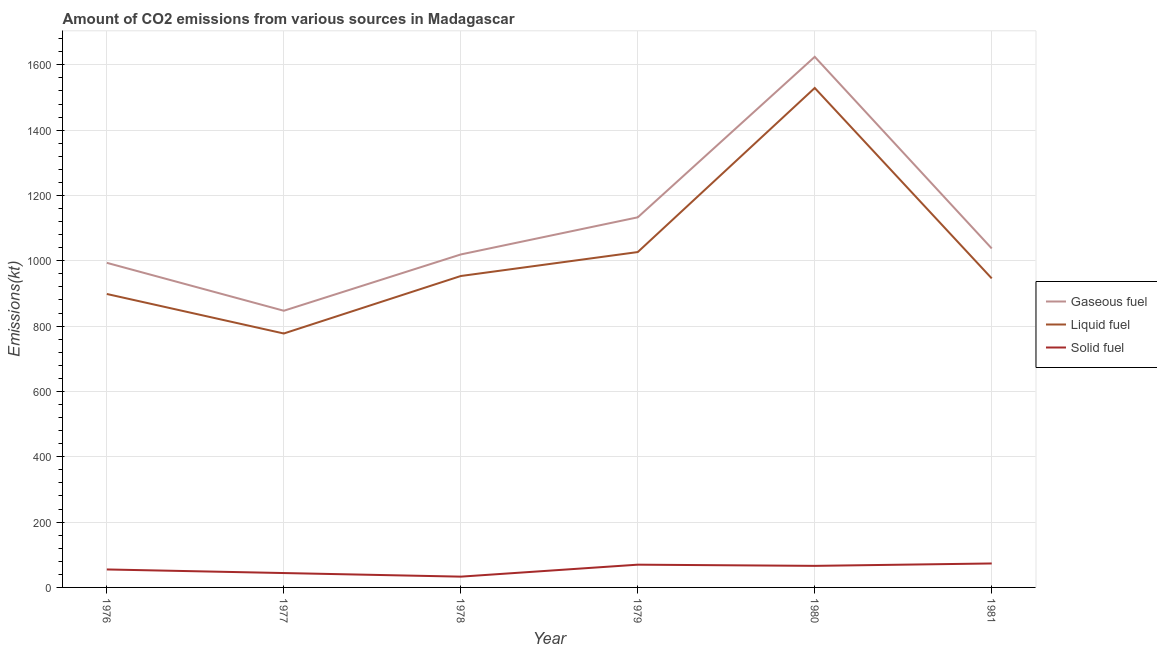How many different coloured lines are there?
Give a very brief answer. 3. Does the line corresponding to amount of co2 emissions from liquid fuel intersect with the line corresponding to amount of co2 emissions from solid fuel?
Keep it short and to the point. No. Is the number of lines equal to the number of legend labels?
Ensure brevity in your answer.  Yes. What is the amount of co2 emissions from liquid fuel in 1976?
Provide a succinct answer. 898.41. Across all years, what is the maximum amount of co2 emissions from gaseous fuel?
Your answer should be compact. 1624.48. Across all years, what is the minimum amount of co2 emissions from solid fuel?
Ensure brevity in your answer.  33. In which year was the amount of co2 emissions from solid fuel maximum?
Give a very brief answer. 1981. In which year was the amount of co2 emissions from solid fuel minimum?
Your answer should be compact. 1978. What is the total amount of co2 emissions from solid fuel in the graph?
Your answer should be compact. 341.03. What is the difference between the amount of co2 emissions from liquid fuel in 1977 and that in 1979?
Give a very brief answer. -249.36. What is the difference between the amount of co2 emissions from liquid fuel in 1979 and the amount of co2 emissions from solid fuel in 1978?
Offer a very short reply. 993.76. What is the average amount of co2 emissions from gaseous fuel per year?
Keep it short and to the point. 1109.27. In the year 1981, what is the difference between the amount of co2 emissions from solid fuel and amount of co2 emissions from liquid fuel?
Give a very brief answer. -872.75. What is the ratio of the amount of co2 emissions from solid fuel in 1976 to that in 1980?
Offer a very short reply. 0.83. Is the amount of co2 emissions from gaseous fuel in 1976 less than that in 1977?
Your answer should be compact. No. Is the difference between the amount of co2 emissions from solid fuel in 1976 and 1981 greater than the difference between the amount of co2 emissions from gaseous fuel in 1976 and 1981?
Provide a short and direct response. Yes. What is the difference between the highest and the second highest amount of co2 emissions from liquid fuel?
Make the answer very short. 502.38. What is the difference between the highest and the lowest amount of co2 emissions from liquid fuel?
Give a very brief answer. 751.73. Is it the case that in every year, the sum of the amount of co2 emissions from gaseous fuel and amount of co2 emissions from liquid fuel is greater than the amount of co2 emissions from solid fuel?
Give a very brief answer. Yes. Does the amount of co2 emissions from liquid fuel monotonically increase over the years?
Ensure brevity in your answer.  No. Is the amount of co2 emissions from liquid fuel strictly greater than the amount of co2 emissions from gaseous fuel over the years?
Give a very brief answer. No. Is the amount of co2 emissions from liquid fuel strictly less than the amount of co2 emissions from solid fuel over the years?
Provide a succinct answer. No. How many years are there in the graph?
Make the answer very short. 6. Does the graph contain any zero values?
Keep it short and to the point. No. Does the graph contain grids?
Give a very brief answer. Yes. Where does the legend appear in the graph?
Provide a short and direct response. Center right. How many legend labels are there?
Your answer should be very brief. 3. How are the legend labels stacked?
Give a very brief answer. Vertical. What is the title of the graph?
Keep it short and to the point. Amount of CO2 emissions from various sources in Madagascar. Does "Taxes on goods and services" appear as one of the legend labels in the graph?
Your response must be concise. No. What is the label or title of the Y-axis?
Offer a terse response. Emissions(kt). What is the Emissions(kt) of Gaseous fuel in 1976?
Your response must be concise. 993.76. What is the Emissions(kt) in Liquid fuel in 1976?
Your response must be concise. 898.41. What is the Emissions(kt) of Solid fuel in 1976?
Give a very brief answer. 55.01. What is the Emissions(kt) in Gaseous fuel in 1977?
Your answer should be very brief. 847.08. What is the Emissions(kt) in Liquid fuel in 1977?
Your answer should be compact. 777.4. What is the Emissions(kt) in Solid fuel in 1977?
Your answer should be very brief. 44. What is the Emissions(kt) of Gaseous fuel in 1978?
Make the answer very short. 1019.43. What is the Emissions(kt) in Liquid fuel in 1978?
Give a very brief answer. 953.42. What is the Emissions(kt) in Solid fuel in 1978?
Keep it short and to the point. 33. What is the Emissions(kt) in Gaseous fuel in 1979?
Provide a short and direct response. 1133.1. What is the Emissions(kt) of Liquid fuel in 1979?
Your answer should be compact. 1026.76. What is the Emissions(kt) of Solid fuel in 1979?
Keep it short and to the point. 69.67. What is the Emissions(kt) of Gaseous fuel in 1980?
Your answer should be very brief. 1624.48. What is the Emissions(kt) of Liquid fuel in 1980?
Make the answer very short. 1529.14. What is the Emissions(kt) in Solid fuel in 1980?
Your response must be concise. 66.01. What is the Emissions(kt) in Gaseous fuel in 1981?
Offer a very short reply. 1037.76. What is the Emissions(kt) in Liquid fuel in 1981?
Give a very brief answer. 946.09. What is the Emissions(kt) in Solid fuel in 1981?
Make the answer very short. 73.34. Across all years, what is the maximum Emissions(kt) in Gaseous fuel?
Provide a succinct answer. 1624.48. Across all years, what is the maximum Emissions(kt) in Liquid fuel?
Give a very brief answer. 1529.14. Across all years, what is the maximum Emissions(kt) of Solid fuel?
Keep it short and to the point. 73.34. Across all years, what is the minimum Emissions(kt) in Gaseous fuel?
Give a very brief answer. 847.08. Across all years, what is the minimum Emissions(kt) of Liquid fuel?
Your answer should be very brief. 777.4. Across all years, what is the minimum Emissions(kt) of Solid fuel?
Your answer should be compact. 33. What is the total Emissions(kt) of Gaseous fuel in the graph?
Your answer should be very brief. 6655.6. What is the total Emissions(kt) in Liquid fuel in the graph?
Provide a short and direct response. 6131.22. What is the total Emissions(kt) of Solid fuel in the graph?
Give a very brief answer. 341.03. What is the difference between the Emissions(kt) in Gaseous fuel in 1976 and that in 1977?
Provide a short and direct response. 146.68. What is the difference between the Emissions(kt) of Liquid fuel in 1976 and that in 1977?
Give a very brief answer. 121.01. What is the difference between the Emissions(kt) in Solid fuel in 1976 and that in 1977?
Make the answer very short. 11. What is the difference between the Emissions(kt) of Gaseous fuel in 1976 and that in 1978?
Your answer should be very brief. -25.67. What is the difference between the Emissions(kt) in Liquid fuel in 1976 and that in 1978?
Ensure brevity in your answer.  -55.01. What is the difference between the Emissions(kt) of Solid fuel in 1976 and that in 1978?
Make the answer very short. 22. What is the difference between the Emissions(kt) of Gaseous fuel in 1976 and that in 1979?
Your response must be concise. -139.35. What is the difference between the Emissions(kt) in Liquid fuel in 1976 and that in 1979?
Make the answer very short. -128.34. What is the difference between the Emissions(kt) of Solid fuel in 1976 and that in 1979?
Keep it short and to the point. -14.67. What is the difference between the Emissions(kt) in Gaseous fuel in 1976 and that in 1980?
Your response must be concise. -630.72. What is the difference between the Emissions(kt) of Liquid fuel in 1976 and that in 1980?
Give a very brief answer. -630.72. What is the difference between the Emissions(kt) of Solid fuel in 1976 and that in 1980?
Your answer should be compact. -11. What is the difference between the Emissions(kt) of Gaseous fuel in 1976 and that in 1981?
Provide a short and direct response. -44. What is the difference between the Emissions(kt) in Liquid fuel in 1976 and that in 1981?
Provide a short and direct response. -47.67. What is the difference between the Emissions(kt) in Solid fuel in 1976 and that in 1981?
Keep it short and to the point. -18.34. What is the difference between the Emissions(kt) in Gaseous fuel in 1977 and that in 1978?
Ensure brevity in your answer.  -172.35. What is the difference between the Emissions(kt) in Liquid fuel in 1977 and that in 1978?
Offer a very short reply. -176.02. What is the difference between the Emissions(kt) of Solid fuel in 1977 and that in 1978?
Your answer should be compact. 11. What is the difference between the Emissions(kt) in Gaseous fuel in 1977 and that in 1979?
Your answer should be very brief. -286.03. What is the difference between the Emissions(kt) of Liquid fuel in 1977 and that in 1979?
Your answer should be very brief. -249.36. What is the difference between the Emissions(kt) in Solid fuel in 1977 and that in 1979?
Your response must be concise. -25.67. What is the difference between the Emissions(kt) in Gaseous fuel in 1977 and that in 1980?
Offer a terse response. -777.4. What is the difference between the Emissions(kt) in Liquid fuel in 1977 and that in 1980?
Your response must be concise. -751.74. What is the difference between the Emissions(kt) of Solid fuel in 1977 and that in 1980?
Give a very brief answer. -22. What is the difference between the Emissions(kt) in Gaseous fuel in 1977 and that in 1981?
Your answer should be very brief. -190.68. What is the difference between the Emissions(kt) in Liquid fuel in 1977 and that in 1981?
Keep it short and to the point. -168.68. What is the difference between the Emissions(kt) of Solid fuel in 1977 and that in 1981?
Make the answer very short. -29.34. What is the difference between the Emissions(kt) of Gaseous fuel in 1978 and that in 1979?
Offer a very short reply. -113.68. What is the difference between the Emissions(kt) of Liquid fuel in 1978 and that in 1979?
Your response must be concise. -73.34. What is the difference between the Emissions(kt) of Solid fuel in 1978 and that in 1979?
Make the answer very short. -36.67. What is the difference between the Emissions(kt) in Gaseous fuel in 1978 and that in 1980?
Make the answer very short. -605.05. What is the difference between the Emissions(kt) of Liquid fuel in 1978 and that in 1980?
Make the answer very short. -575.72. What is the difference between the Emissions(kt) in Solid fuel in 1978 and that in 1980?
Ensure brevity in your answer.  -33. What is the difference between the Emissions(kt) of Gaseous fuel in 1978 and that in 1981?
Give a very brief answer. -18.34. What is the difference between the Emissions(kt) in Liquid fuel in 1978 and that in 1981?
Your response must be concise. 7.33. What is the difference between the Emissions(kt) in Solid fuel in 1978 and that in 1981?
Your answer should be very brief. -40.34. What is the difference between the Emissions(kt) of Gaseous fuel in 1979 and that in 1980?
Offer a very short reply. -491.38. What is the difference between the Emissions(kt) of Liquid fuel in 1979 and that in 1980?
Your response must be concise. -502.38. What is the difference between the Emissions(kt) of Solid fuel in 1979 and that in 1980?
Your response must be concise. 3.67. What is the difference between the Emissions(kt) in Gaseous fuel in 1979 and that in 1981?
Provide a succinct answer. 95.34. What is the difference between the Emissions(kt) in Liquid fuel in 1979 and that in 1981?
Provide a short and direct response. 80.67. What is the difference between the Emissions(kt) of Solid fuel in 1979 and that in 1981?
Make the answer very short. -3.67. What is the difference between the Emissions(kt) of Gaseous fuel in 1980 and that in 1981?
Give a very brief answer. 586.72. What is the difference between the Emissions(kt) of Liquid fuel in 1980 and that in 1981?
Your answer should be very brief. 583.05. What is the difference between the Emissions(kt) of Solid fuel in 1980 and that in 1981?
Give a very brief answer. -7.33. What is the difference between the Emissions(kt) in Gaseous fuel in 1976 and the Emissions(kt) in Liquid fuel in 1977?
Your response must be concise. 216.35. What is the difference between the Emissions(kt) of Gaseous fuel in 1976 and the Emissions(kt) of Solid fuel in 1977?
Your response must be concise. 949.75. What is the difference between the Emissions(kt) in Liquid fuel in 1976 and the Emissions(kt) in Solid fuel in 1977?
Your response must be concise. 854.41. What is the difference between the Emissions(kt) in Gaseous fuel in 1976 and the Emissions(kt) in Liquid fuel in 1978?
Offer a terse response. 40.34. What is the difference between the Emissions(kt) of Gaseous fuel in 1976 and the Emissions(kt) of Solid fuel in 1978?
Ensure brevity in your answer.  960.75. What is the difference between the Emissions(kt) in Liquid fuel in 1976 and the Emissions(kt) in Solid fuel in 1978?
Ensure brevity in your answer.  865.41. What is the difference between the Emissions(kt) of Gaseous fuel in 1976 and the Emissions(kt) of Liquid fuel in 1979?
Offer a terse response. -33. What is the difference between the Emissions(kt) of Gaseous fuel in 1976 and the Emissions(kt) of Solid fuel in 1979?
Provide a short and direct response. 924.08. What is the difference between the Emissions(kt) in Liquid fuel in 1976 and the Emissions(kt) in Solid fuel in 1979?
Keep it short and to the point. 828.74. What is the difference between the Emissions(kt) in Gaseous fuel in 1976 and the Emissions(kt) in Liquid fuel in 1980?
Your answer should be very brief. -535.38. What is the difference between the Emissions(kt) in Gaseous fuel in 1976 and the Emissions(kt) in Solid fuel in 1980?
Offer a terse response. 927.75. What is the difference between the Emissions(kt) of Liquid fuel in 1976 and the Emissions(kt) of Solid fuel in 1980?
Provide a short and direct response. 832.41. What is the difference between the Emissions(kt) in Gaseous fuel in 1976 and the Emissions(kt) in Liquid fuel in 1981?
Your answer should be compact. 47.67. What is the difference between the Emissions(kt) in Gaseous fuel in 1976 and the Emissions(kt) in Solid fuel in 1981?
Give a very brief answer. 920.42. What is the difference between the Emissions(kt) of Liquid fuel in 1976 and the Emissions(kt) of Solid fuel in 1981?
Offer a very short reply. 825.08. What is the difference between the Emissions(kt) of Gaseous fuel in 1977 and the Emissions(kt) of Liquid fuel in 1978?
Make the answer very short. -106.34. What is the difference between the Emissions(kt) in Gaseous fuel in 1977 and the Emissions(kt) in Solid fuel in 1978?
Offer a very short reply. 814.07. What is the difference between the Emissions(kt) of Liquid fuel in 1977 and the Emissions(kt) of Solid fuel in 1978?
Offer a very short reply. 744.4. What is the difference between the Emissions(kt) of Gaseous fuel in 1977 and the Emissions(kt) of Liquid fuel in 1979?
Make the answer very short. -179.68. What is the difference between the Emissions(kt) in Gaseous fuel in 1977 and the Emissions(kt) in Solid fuel in 1979?
Keep it short and to the point. 777.4. What is the difference between the Emissions(kt) in Liquid fuel in 1977 and the Emissions(kt) in Solid fuel in 1979?
Keep it short and to the point. 707.73. What is the difference between the Emissions(kt) in Gaseous fuel in 1977 and the Emissions(kt) in Liquid fuel in 1980?
Provide a short and direct response. -682.06. What is the difference between the Emissions(kt) of Gaseous fuel in 1977 and the Emissions(kt) of Solid fuel in 1980?
Ensure brevity in your answer.  781.07. What is the difference between the Emissions(kt) of Liquid fuel in 1977 and the Emissions(kt) of Solid fuel in 1980?
Provide a succinct answer. 711.4. What is the difference between the Emissions(kt) of Gaseous fuel in 1977 and the Emissions(kt) of Liquid fuel in 1981?
Keep it short and to the point. -99.01. What is the difference between the Emissions(kt) in Gaseous fuel in 1977 and the Emissions(kt) in Solid fuel in 1981?
Your answer should be very brief. 773.74. What is the difference between the Emissions(kt) in Liquid fuel in 1977 and the Emissions(kt) in Solid fuel in 1981?
Keep it short and to the point. 704.06. What is the difference between the Emissions(kt) of Gaseous fuel in 1978 and the Emissions(kt) of Liquid fuel in 1979?
Provide a succinct answer. -7.33. What is the difference between the Emissions(kt) of Gaseous fuel in 1978 and the Emissions(kt) of Solid fuel in 1979?
Your answer should be compact. 949.75. What is the difference between the Emissions(kt) of Liquid fuel in 1978 and the Emissions(kt) of Solid fuel in 1979?
Ensure brevity in your answer.  883.75. What is the difference between the Emissions(kt) in Gaseous fuel in 1978 and the Emissions(kt) in Liquid fuel in 1980?
Offer a very short reply. -509.71. What is the difference between the Emissions(kt) in Gaseous fuel in 1978 and the Emissions(kt) in Solid fuel in 1980?
Your answer should be compact. 953.42. What is the difference between the Emissions(kt) in Liquid fuel in 1978 and the Emissions(kt) in Solid fuel in 1980?
Keep it short and to the point. 887.41. What is the difference between the Emissions(kt) in Gaseous fuel in 1978 and the Emissions(kt) in Liquid fuel in 1981?
Offer a very short reply. 73.34. What is the difference between the Emissions(kt) of Gaseous fuel in 1978 and the Emissions(kt) of Solid fuel in 1981?
Your answer should be compact. 946.09. What is the difference between the Emissions(kt) of Liquid fuel in 1978 and the Emissions(kt) of Solid fuel in 1981?
Offer a very short reply. 880.08. What is the difference between the Emissions(kt) in Gaseous fuel in 1979 and the Emissions(kt) in Liquid fuel in 1980?
Give a very brief answer. -396.04. What is the difference between the Emissions(kt) of Gaseous fuel in 1979 and the Emissions(kt) of Solid fuel in 1980?
Offer a terse response. 1067.1. What is the difference between the Emissions(kt) of Liquid fuel in 1979 and the Emissions(kt) of Solid fuel in 1980?
Your response must be concise. 960.75. What is the difference between the Emissions(kt) in Gaseous fuel in 1979 and the Emissions(kt) in Liquid fuel in 1981?
Provide a succinct answer. 187.02. What is the difference between the Emissions(kt) in Gaseous fuel in 1979 and the Emissions(kt) in Solid fuel in 1981?
Ensure brevity in your answer.  1059.76. What is the difference between the Emissions(kt) of Liquid fuel in 1979 and the Emissions(kt) of Solid fuel in 1981?
Ensure brevity in your answer.  953.42. What is the difference between the Emissions(kt) of Gaseous fuel in 1980 and the Emissions(kt) of Liquid fuel in 1981?
Offer a terse response. 678.39. What is the difference between the Emissions(kt) of Gaseous fuel in 1980 and the Emissions(kt) of Solid fuel in 1981?
Ensure brevity in your answer.  1551.14. What is the difference between the Emissions(kt) of Liquid fuel in 1980 and the Emissions(kt) of Solid fuel in 1981?
Make the answer very short. 1455.8. What is the average Emissions(kt) of Gaseous fuel per year?
Make the answer very short. 1109.27. What is the average Emissions(kt) in Liquid fuel per year?
Provide a succinct answer. 1021.87. What is the average Emissions(kt) in Solid fuel per year?
Give a very brief answer. 56.84. In the year 1976, what is the difference between the Emissions(kt) of Gaseous fuel and Emissions(kt) of Liquid fuel?
Your response must be concise. 95.34. In the year 1976, what is the difference between the Emissions(kt) in Gaseous fuel and Emissions(kt) in Solid fuel?
Your response must be concise. 938.75. In the year 1976, what is the difference between the Emissions(kt) in Liquid fuel and Emissions(kt) in Solid fuel?
Offer a very short reply. 843.41. In the year 1977, what is the difference between the Emissions(kt) of Gaseous fuel and Emissions(kt) of Liquid fuel?
Your answer should be very brief. 69.67. In the year 1977, what is the difference between the Emissions(kt) of Gaseous fuel and Emissions(kt) of Solid fuel?
Ensure brevity in your answer.  803.07. In the year 1977, what is the difference between the Emissions(kt) of Liquid fuel and Emissions(kt) of Solid fuel?
Give a very brief answer. 733.4. In the year 1978, what is the difference between the Emissions(kt) in Gaseous fuel and Emissions(kt) in Liquid fuel?
Your answer should be compact. 66.01. In the year 1978, what is the difference between the Emissions(kt) of Gaseous fuel and Emissions(kt) of Solid fuel?
Provide a short and direct response. 986.42. In the year 1978, what is the difference between the Emissions(kt) of Liquid fuel and Emissions(kt) of Solid fuel?
Your answer should be very brief. 920.42. In the year 1979, what is the difference between the Emissions(kt) in Gaseous fuel and Emissions(kt) in Liquid fuel?
Offer a terse response. 106.34. In the year 1979, what is the difference between the Emissions(kt) of Gaseous fuel and Emissions(kt) of Solid fuel?
Give a very brief answer. 1063.43. In the year 1979, what is the difference between the Emissions(kt) in Liquid fuel and Emissions(kt) in Solid fuel?
Ensure brevity in your answer.  957.09. In the year 1980, what is the difference between the Emissions(kt) of Gaseous fuel and Emissions(kt) of Liquid fuel?
Your answer should be very brief. 95.34. In the year 1980, what is the difference between the Emissions(kt) of Gaseous fuel and Emissions(kt) of Solid fuel?
Make the answer very short. 1558.47. In the year 1980, what is the difference between the Emissions(kt) of Liquid fuel and Emissions(kt) of Solid fuel?
Keep it short and to the point. 1463.13. In the year 1981, what is the difference between the Emissions(kt) in Gaseous fuel and Emissions(kt) in Liquid fuel?
Ensure brevity in your answer.  91.67. In the year 1981, what is the difference between the Emissions(kt) of Gaseous fuel and Emissions(kt) of Solid fuel?
Keep it short and to the point. 964.42. In the year 1981, what is the difference between the Emissions(kt) in Liquid fuel and Emissions(kt) in Solid fuel?
Provide a succinct answer. 872.75. What is the ratio of the Emissions(kt) of Gaseous fuel in 1976 to that in 1977?
Ensure brevity in your answer.  1.17. What is the ratio of the Emissions(kt) in Liquid fuel in 1976 to that in 1977?
Give a very brief answer. 1.16. What is the ratio of the Emissions(kt) of Solid fuel in 1976 to that in 1977?
Offer a very short reply. 1.25. What is the ratio of the Emissions(kt) in Gaseous fuel in 1976 to that in 1978?
Give a very brief answer. 0.97. What is the ratio of the Emissions(kt) of Liquid fuel in 1976 to that in 1978?
Keep it short and to the point. 0.94. What is the ratio of the Emissions(kt) in Gaseous fuel in 1976 to that in 1979?
Make the answer very short. 0.88. What is the ratio of the Emissions(kt) in Liquid fuel in 1976 to that in 1979?
Provide a succinct answer. 0.88. What is the ratio of the Emissions(kt) in Solid fuel in 1976 to that in 1979?
Your answer should be compact. 0.79. What is the ratio of the Emissions(kt) in Gaseous fuel in 1976 to that in 1980?
Offer a terse response. 0.61. What is the ratio of the Emissions(kt) in Liquid fuel in 1976 to that in 1980?
Your response must be concise. 0.59. What is the ratio of the Emissions(kt) in Solid fuel in 1976 to that in 1980?
Offer a terse response. 0.83. What is the ratio of the Emissions(kt) in Gaseous fuel in 1976 to that in 1981?
Give a very brief answer. 0.96. What is the ratio of the Emissions(kt) in Liquid fuel in 1976 to that in 1981?
Provide a succinct answer. 0.95. What is the ratio of the Emissions(kt) in Solid fuel in 1976 to that in 1981?
Offer a very short reply. 0.75. What is the ratio of the Emissions(kt) in Gaseous fuel in 1977 to that in 1978?
Provide a succinct answer. 0.83. What is the ratio of the Emissions(kt) of Liquid fuel in 1977 to that in 1978?
Your answer should be very brief. 0.82. What is the ratio of the Emissions(kt) of Solid fuel in 1977 to that in 1978?
Make the answer very short. 1.33. What is the ratio of the Emissions(kt) of Gaseous fuel in 1977 to that in 1979?
Provide a succinct answer. 0.75. What is the ratio of the Emissions(kt) of Liquid fuel in 1977 to that in 1979?
Make the answer very short. 0.76. What is the ratio of the Emissions(kt) in Solid fuel in 1977 to that in 1979?
Give a very brief answer. 0.63. What is the ratio of the Emissions(kt) in Gaseous fuel in 1977 to that in 1980?
Offer a terse response. 0.52. What is the ratio of the Emissions(kt) in Liquid fuel in 1977 to that in 1980?
Offer a terse response. 0.51. What is the ratio of the Emissions(kt) in Gaseous fuel in 1977 to that in 1981?
Your response must be concise. 0.82. What is the ratio of the Emissions(kt) of Liquid fuel in 1977 to that in 1981?
Offer a terse response. 0.82. What is the ratio of the Emissions(kt) in Gaseous fuel in 1978 to that in 1979?
Your response must be concise. 0.9. What is the ratio of the Emissions(kt) in Liquid fuel in 1978 to that in 1979?
Provide a succinct answer. 0.93. What is the ratio of the Emissions(kt) in Solid fuel in 1978 to that in 1979?
Your answer should be compact. 0.47. What is the ratio of the Emissions(kt) of Gaseous fuel in 1978 to that in 1980?
Your answer should be very brief. 0.63. What is the ratio of the Emissions(kt) of Liquid fuel in 1978 to that in 1980?
Provide a short and direct response. 0.62. What is the ratio of the Emissions(kt) of Gaseous fuel in 1978 to that in 1981?
Keep it short and to the point. 0.98. What is the ratio of the Emissions(kt) of Liquid fuel in 1978 to that in 1981?
Offer a terse response. 1.01. What is the ratio of the Emissions(kt) in Solid fuel in 1978 to that in 1981?
Offer a very short reply. 0.45. What is the ratio of the Emissions(kt) of Gaseous fuel in 1979 to that in 1980?
Ensure brevity in your answer.  0.7. What is the ratio of the Emissions(kt) of Liquid fuel in 1979 to that in 1980?
Provide a succinct answer. 0.67. What is the ratio of the Emissions(kt) of Solid fuel in 1979 to that in 1980?
Offer a terse response. 1.06. What is the ratio of the Emissions(kt) in Gaseous fuel in 1979 to that in 1981?
Provide a succinct answer. 1.09. What is the ratio of the Emissions(kt) in Liquid fuel in 1979 to that in 1981?
Your answer should be compact. 1.09. What is the ratio of the Emissions(kt) of Solid fuel in 1979 to that in 1981?
Offer a very short reply. 0.95. What is the ratio of the Emissions(kt) of Gaseous fuel in 1980 to that in 1981?
Provide a short and direct response. 1.57. What is the ratio of the Emissions(kt) in Liquid fuel in 1980 to that in 1981?
Provide a short and direct response. 1.62. What is the difference between the highest and the second highest Emissions(kt) of Gaseous fuel?
Ensure brevity in your answer.  491.38. What is the difference between the highest and the second highest Emissions(kt) of Liquid fuel?
Provide a short and direct response. 502.38. What is the difference between the highest and the second highest Emissions(kt) in Solid fuel?
Your answer should be compact. 3.67. What is the difference between the highest and the lowest Emissions(kt) in Gaseous fuel?
Make the answer very short. 777.4. What is the difference between the highest and the lowest Emissions(kt) in Liquid fuel?
Your answer should be very brief. 751.74. What is the difference between the highest and the lowest Emissions(kt) in Solid fuel?
Offer a very short reply. 40.34. 